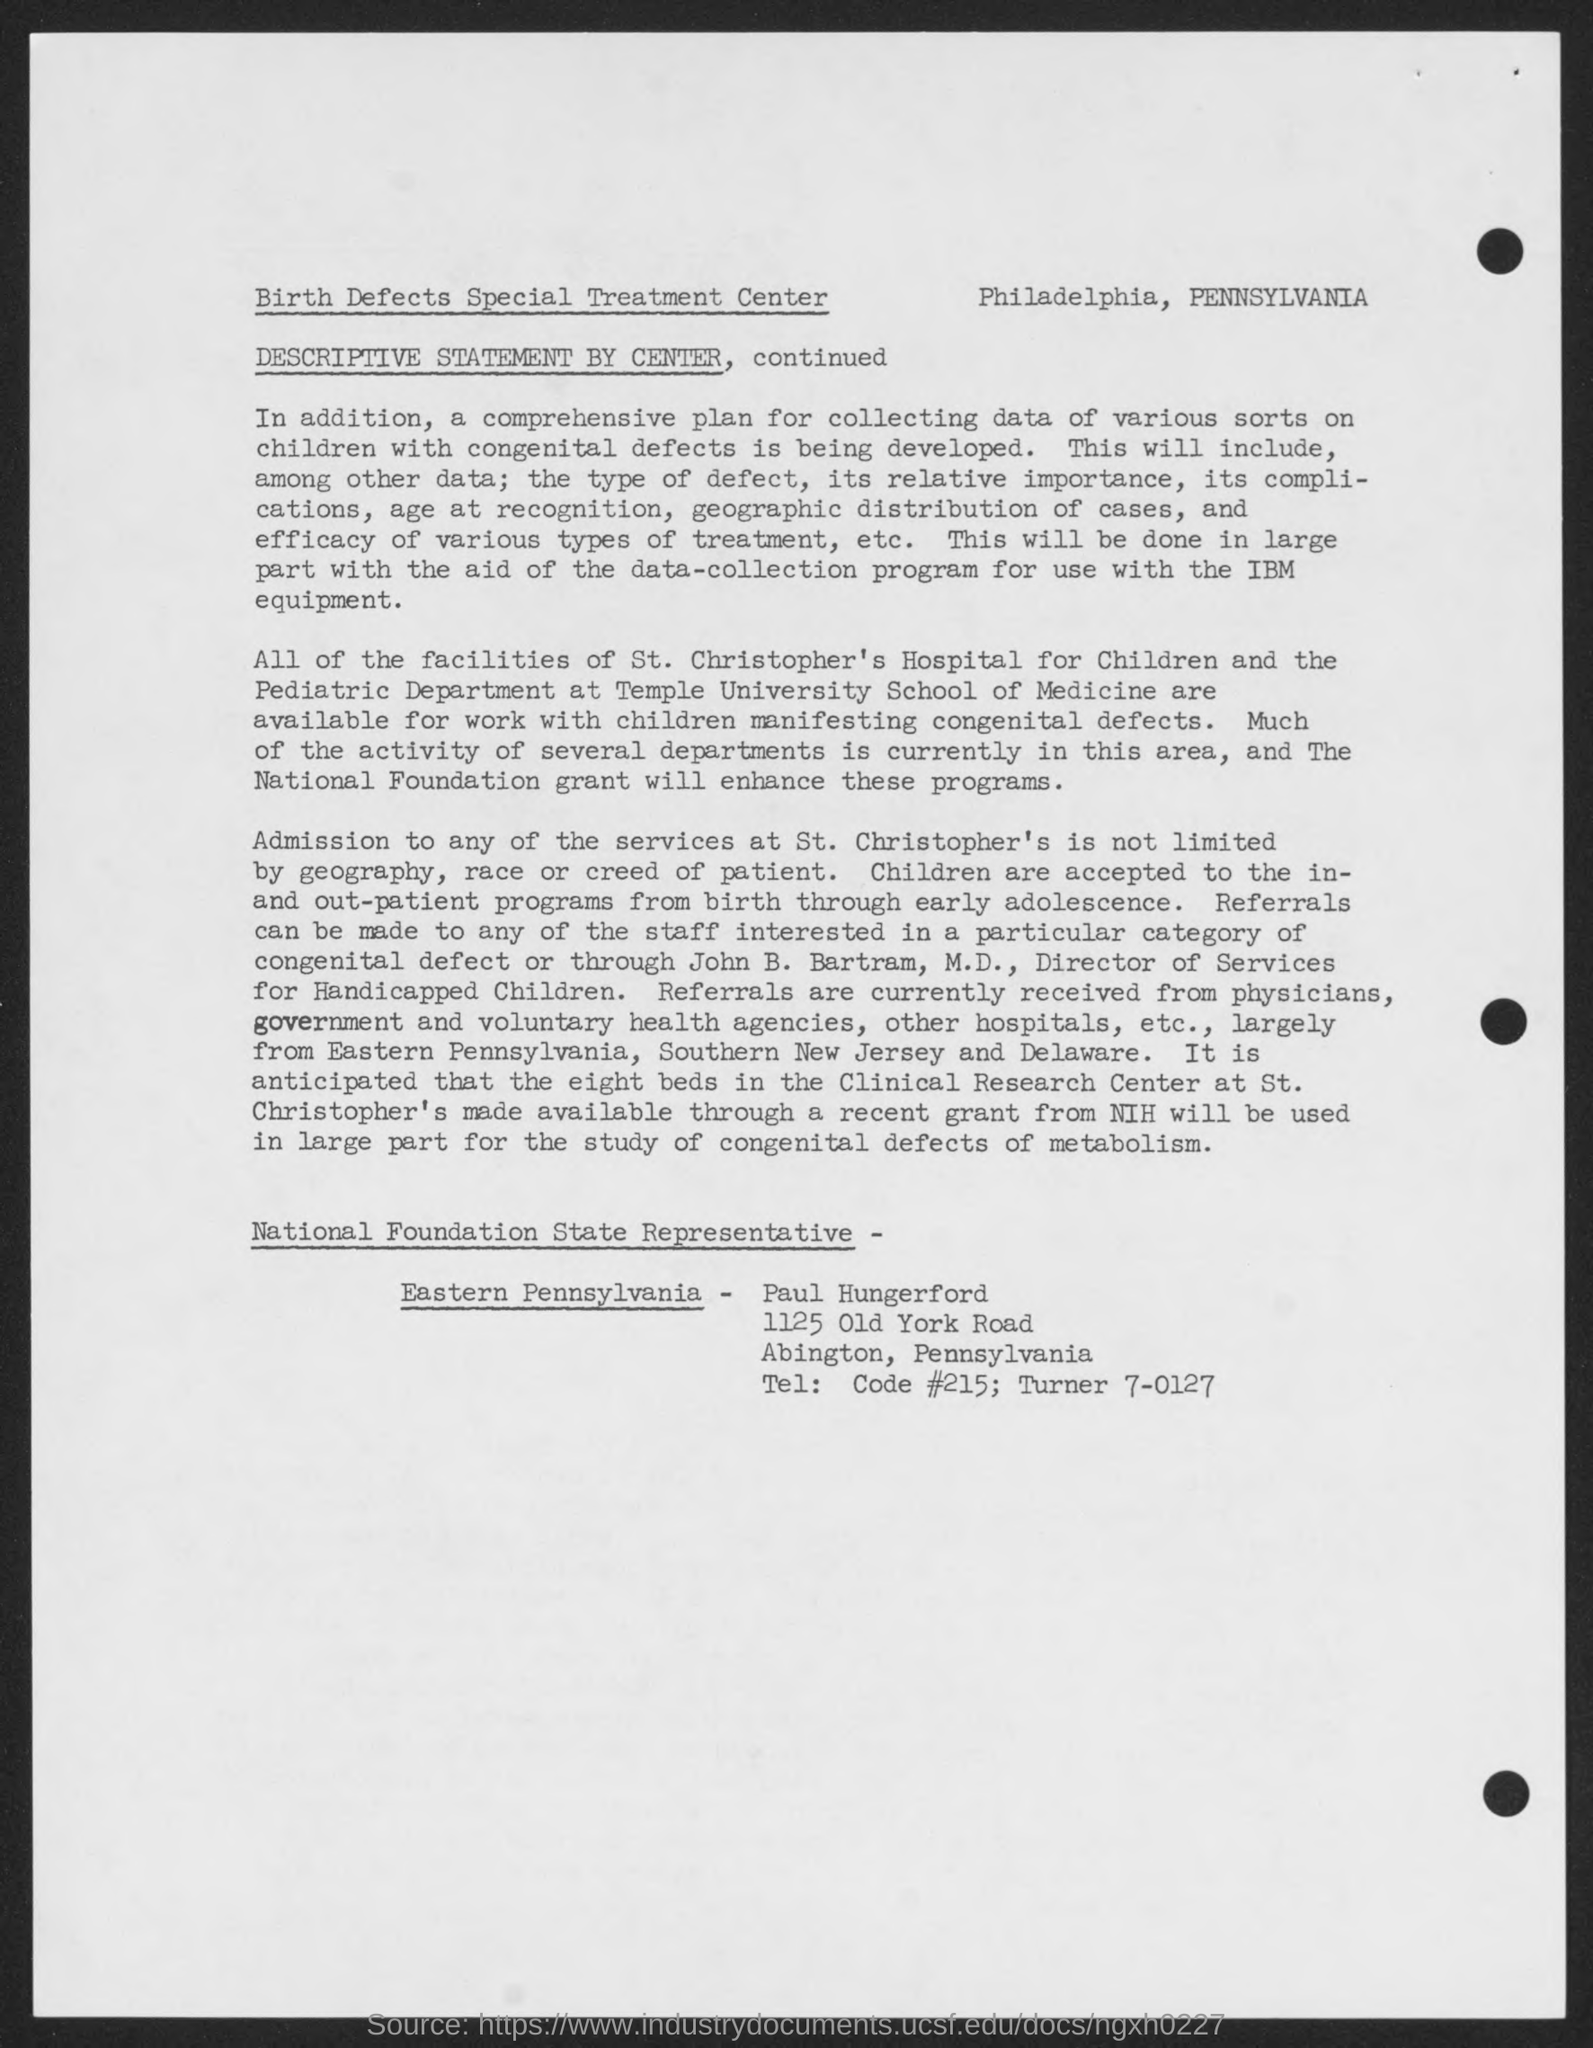Give some essential details in this illustration. Admissions to St. Christopher hospital are not based on the patient's geography, race, or creed. 